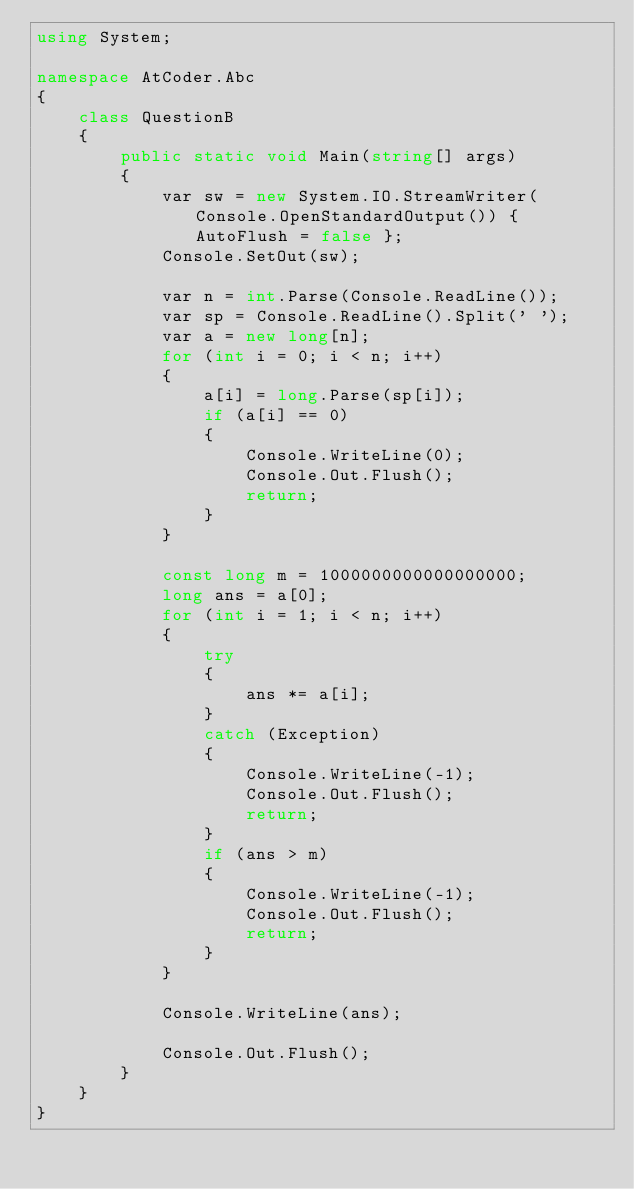<code> <loc_0><loc_0><loc_500><loc_500><_C#_>using System;

namespace AtCoder.Abc
{
    class QuestionB
    {
        public static void Main(string[] args)
        {
            var sw = new System.IO.StreamWriter(Console.OpenStandardOutput()) { AutoFlush = false };
            Console.SetOut(sw);

            var n = int.Parse(Console.ReadLine());
            var sp = Console.ReadLine().Split(' ');
            var a = new long[n];
            for (int i = 0; i < n; i++)
            {
                a[i] = long.Parse(sp[i]);
                if (a[i] == 0)
                {
                    Console.WriteLine(0);
                    Console.Out.Flush();
                    return;
                }
            }

            const long m = 1000000000000000000;
            long ans = a[0];
            for (int i = 1; i < n; i++)
            {
                try
                {
                    ans *= a[i];
                }
                catch (Exception)
                {
                    Console.WriteLine(-1);
                    Console.Out.Flush();
                    return;
                }
                if (ans > m)
                {
                    Console.WriteLine(-1);
                    Console.Out.Flush();
                    return;
                }
            }

            Console.WriteLine(ans);

            Console.Out.Flush();
        }
    }
}
</code> 